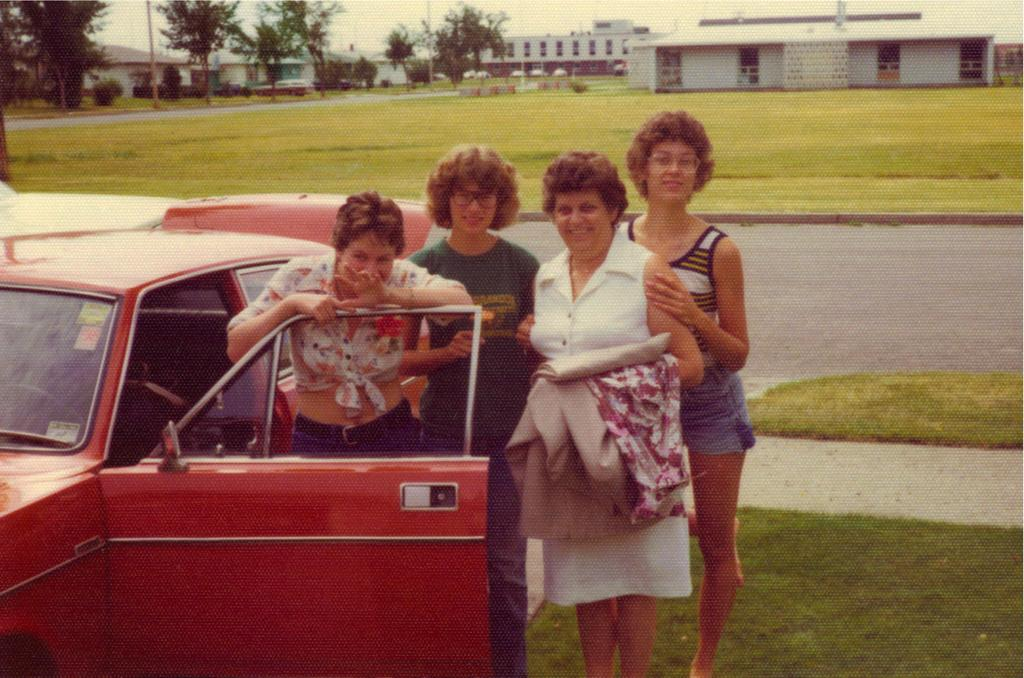What type of structures can be seen in the image? There are buildings in the image. What natural elements are present in the image? There are trees and grass on the ground in the image. Who is present in the image? There are women standing in the image. What type of vehicle can be seen in the image? There is a red color car in the image. Where is the shop located in the image? There is no shop present in the image. What type of cover is on the red car in the image? The red car in the image does not have any cover; it is visible without any additional covering. 